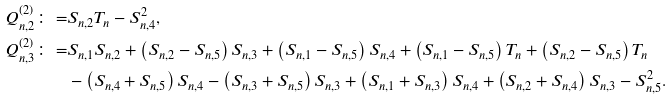Convert formula to latex. <formula><loc_0><loc_0><loc_500><loc_500>Q _ { n , 2 } ^ { ( 2 ) } \colon = & S _ { n , 2 } T _ { n } - S _ { n , 4 } ^ { 2 } , \\ Q _ { n , 3 } ^ { ( 2 ) } \colon = & S _ { n , 1 } S _ { n , 2 } + \left ( S _ { n , 2 } - S _ { n , 5 } \right ) S _ { n , 3 } + \left ( S _ { n , 1 } - S _ { n , 5 } \right ) S _ { n , 4 } + \left ( S _ { n , 1 } - S _ { n , 5 } \right ) T _ { n } + \left ( S _ { n , 2 } - S _ { n , 5 } \right ) T _ { n } \\ & - \left ( S _ { n , 4 } + S _ { n , 5 } \right ) S _ { n , 4 } - \left ( S _ { n , 3 } + S _ { n , 5 } \right ) S _ { n , 3 } + \left ( S _ { n , 1 } + S _ { n , 3 } \right ) S _ { n , 4 } + \left ( S _ { n , 2 } + S _ { n , 4 } \right ) S _ { n , 3 } - S _ { n , 5 } ^ { 2 } .</formula> 